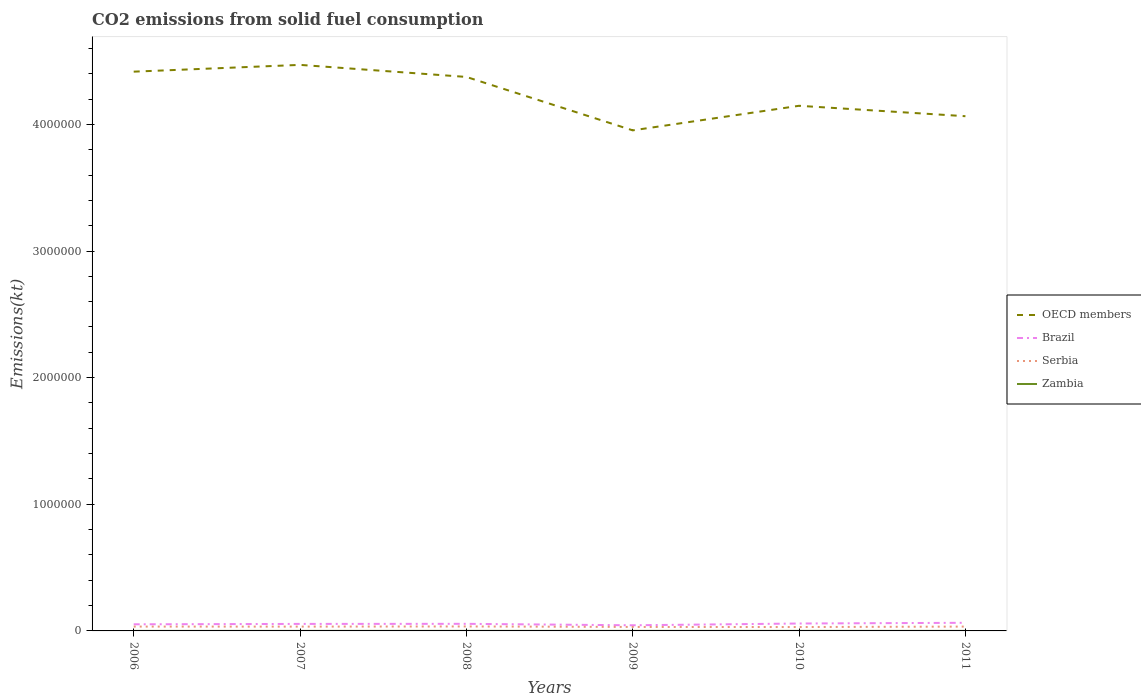Does the line corresponding to Zambia intersect with the line corresponding to OECD members?
Provide a short and direct response. No. Is the number of lines equal to the number of legend labels?
Offer a very short reply. Yes. Across all years, what is the maximum amount of CO2 emitted in Zambia?
Offer a very short reply. 132.01. In which year was the amount of CO2 emitted in Brazil maximum?
Give a very brief answer. 2009. What is the total amount of CO2 emitted in Serbia in the graph?
Keep it short and to the point. 238.36. What is the difference between the highest and the second highest amount of CO2 emitted in OECD members?
Keep it short and to the point. 5.17e+05. Is the amount of CO2 emitted in OECD members strictly greater than the amount of CO2 emitted in Serbia over the years?
Provide a short and direct response. No. How many years are there in the graph?
Your answer should be compact. 6. Does the graph contain any zero values?
Your response must be concise. No. Does the graph contain grids?
Keep it short and to the point. No. How many legend labels are there?
Ensure brevity in your answer.  4. What is the title of the graph?
Your answer should be compact. CO2 emissions from solid fuel consumption. Does "Bahrain" appear as one of the legend labels in the graph?
Your answer should be compact. No. What is the label or title of the Y-axis?
Your response must be concise. Emissions(kt). What is the Emissions(kt) of OECD members in 2006?
Ensure brevity in your answer.  4.42e+06. What is the Emissions(kt) of Brazil in 2006?
Make the answer very short. 5.23e+04. What is the Emissions(kt) of Serbia in 2006?
Your response must be concise. 3.42e+04. What is the Emissions(kt) of Zambia in 2006?
Make the answer very short. 132.01. What is the Emissions(kt) in OECD members in 2007?
Provide a short and direct response. 4.47e+06. What is the Emissions(kt) in Brazil in 2007?
Provide a succinct answer. 5.53e+04. What is the Emissions(kt) of Serbia in 2007?
Provide a short and direct response. 3.40e+04. What is the Emissions(kt) in Zambia in 2007?
Ensure brevity in your answer.  293.36. What is the Emissions(kt) in OECD members in 2008?
Your answer should be compact. 4.37e+06. What is the Emissions(kt) of Brazil in 2008?
Make the answer very short. 5.60e+04. What is the Emissions(kt) of Serbia in 2008?
Keep it short and to the point. 3.53e+04. What is the Emissions(kt) in Zambia in 2008?
Ensure brevity in your answer.  315.36. What is the Emissions(kt) of OECD members in 2009?
Your answer should be very brief. 3.95e+06. What is the Emissions(kt) of Brazil in 2009?
Provide a succinct answer. 4.45e+04. What is the Emissions(kt) in Serbia in 2009?
Your response must be concise. 3.14e+04. What is the Emissions(kt) in Zambia in 2009?
Offer a very short reply. 407.04. What is the Emissions(kt) in OECD members in 2010?
Your answer should be compact. 4.15e+06. What is the Emissions(kt) in Brazil in 2010?
Keep it short and to the point. 5.85e+04. What is the Emissions(kt) in Serbia in 2010?
Your answer should be compact. 3.07e+04. What is the Emissions(kt) in Zambia in 2010?
Make the answer very short. 381.37. What is the Emissions(kt) of OECD members in 2011?
Give a very brief answer. 4.06e+06. What is the Emissions(kt) of Brazil in 2011?
Make the answer very short. 6.42e+04. What is the Emissions(kt) in Serbia in 2011?
Make the answer very short. 3.42e+04. What is the Emissions(kt) in Zambia in 2011?
Provide a short and direct response. 267.69. Across all years, what is the maximum Emissions(kt) in OECD members?
Your answer should be very brief. 4.47e+06. Across all years, what is the maximum Emissions(kt) in Brazil?
Your answer should be very brief. 6.42e+04. Across all years, what is the maximum Emissions(kt) in Serbia?
Your answer should be compact. 3.53e+04. Across all years, what is the maximum Emissions(kt) in Zambia?
Your answer should be compact. 407.04. Across all years, what is the minimum Emissions(kt) in OECD members?
Your response must be concise. 3.95e+06. Across all years, what is the minimum Emissions(kt) in Brazil?
Your answer should be very brief. 4.45e+04. Across all years, what is the minimum Emissions(kt) in Serbia?
Provide a succinct answer. 3.07e+04. Across all years, what is the minimum Emissions(kt) in Zambia?
Offer a very short reply. 132.01. What is the total Emissions(kt) of OECD members in the graph?
Provide a succinct answer. 2.54e+07. What is the total Emissions(kt) in Brazil in the graph?
Offer a terse response. 3.31e+05. What is the total Emissions(kt) in Serbia in the graph?
Offer a terse response. 2.00e+05. What is the total Emissions(kt) of Zambia in the graph?
Provide a succinct answer. 1796.83. What is the difference between the Emissions(kt) in OECD members in 2006 and that in 2007?
Provide a short and direct response. -5.35e+04. What is the difference between the Emissions(kt) of Brazil in 2006 and that in 2007?
Keep it short and to the point. -3076.61. What is the difference between the Emissions(kt) in Serbia in 2006 and that in 2007?
Your response must be concise. 238.35. What is the difference between the Emissions(kt) of Zambia in 2006 and that in 2007?
Give a very brief answer. -161.35. What is the difference between the Emissions(kt) in OECD members in 2006 and that in 2008?
Provide a succinct answer. 4.17e+04. What is the difference between the Emissions(kt) of Brazil in 2006 and that in 2008?
Your answer should be compact. -3736.67. What is the difference between the Emissions(kt) of Serbia in 2006 and that in 2008?
Provide a succinct answer. -1056.1. What is the difference between the Emissions(kt) of Zambia in 2006 and that in 2008?
Provide a succinct answer. -183.35. What is the difference between the Emissions(kt) of OECD members in 2006 and that in 2009?
Keep it short and to the point. 4.64e+05. What is the difference between the Emissions(kt) of Brazil in 2006 and that in 2009?
Offer a very short reply. 7774.04. What is the difference between the Emissions(kt) of Serbia in 2006 and that in 2009?
Your answer should be very brief. 2882.26. What is the difference between the Emissions(kt) of Zambia in 2006 and that in 2009?
Ensure brevity in your answer.  -275.02. What is the difference between the Emissions(kt) in OECD members in 2006 and that in 2010?
Make the answer very short. 2.70e+05. What is the difference between the Emissions(kt) in Brazil in 2006 and that in 2010?
Your answer should be compact. -6274.24. What is the difference between the Emissions(kt) of Serbia in 2006 and that in 2010?
Make the answer very short. 3564.32. What is the difference between the Emissions(kt) of Zambia in 2006 and that in 2010?
Provide a short and direct response. -249.36. What is the difference between the Emissions(kt) of OECD members in 2006 and that in 2011?
Give a very brief answer. 3.52e+05. What is the difference between the Emissions(kt) of Brazil in 2006 and that in 2011?
Offer a terse response. -1.19e+04. What is the difference between the Emissions(kt) of Serbia in 2006 and that in 2011?
Keep it short and to the point. 62.34. What is the difference between the Emissions(kt) of Zambia in 2006 and that in 2011?
Your answer should be compact. -135.68. What is the difference between the Emissions(kt) in OECD members in 2007 and that in 2008?
Your answer should be very brief. 9.52e+04. What is the difference between the Emissions(kt) of Brazil in 2007 and that in 2008?
Your answer should be very brief. -660.06. What is the difference between the Emissions(kt) in Serbia in 2007 and that in 2008?
Provide a short and direct response. -1294.45. What is the difference between the Emissions(kt) of Zambia in 2007 and that in 2008?
Your response must be concise. -22. What is the difference between the Emissions(kt) of OECD members in 2007 and that in 2009?
Your response must be concise. 5.17e+05. What is the difference between the Emissions(kt) in Brazil in 2007 and that in 2009?
Provide a succinct answer. 1.09e+04. What is the difference between the Emissions(kt) in Serbia in 2007 and that in 2009?
Keep it short and to the point. 2643.91. What is the difference between the Emissions(kt) in Zambia in 2007 and that in 2009?
Your answer should be very brief. -113.68. What is the difference between the Emissions(kt) of OECD members in 2007 and that in 2010?
Offer a terse response. 3.23e+05. What is the difference between the Emissions(kt) of Brazil in 2007 and that in 2010?
Your answer should be very brief. -3197.62. What is the difference between the Emissions(kt) in Serbia in 2007 and that in 2010?
Offer a very short reply. 3325.97. What is the difference between the Emissions(kt) of Zambia in 2007 and that in 2010?
Ensure brevity in your answer.  -88.01. What is the difference between the Emissions(kt) in OECD members in 2007 and that in 2011?
Provide a short and direct response. 4.05e+05. What is the difference between the Emissions(kt) of Brazil in 2007 and that in 2011?
Keep it short and to the point. -8819.14. What is the difference between the Emissions(kt) in Serbia in 2007 and that in 2011?
Your answer should be very brief. -176.02. What is the difference between the Emissions(kt) in Zambia in 2007 and that in 2011?
Offer a very short reply. 25.67. What is the difference between the Emissions(kt) in OECD members in 2008 and that in 2009?
Give a very brief answer. 4.22e+05. What is the difference between the Emissions(kt) in Brazil in 2008 and that in 2009?
Your answer should be very brief. 1.15e+04. What is the difference between the Emissions(kt) in Serbia in 2008 and that in 2009?
Provide a succinct answer. 3938.36. What is the difference between the Emissions(kt) of Zambia in 2008 and that in 2009?
Make the answer very short. -91.67. What is the difference between the Emissions(kt) of OECD members in 2008 and that in 2010?
Ensure brevity in your answer.  2.28e+05. What is the difference between the Emissions(kt) in Brazil in 2008 and that in 2010?
Keep it short and to the point. -2537.56. What is the difference between the Emissions(kt) in Serbia in 2008 and that in 2010?
Make the answer very short. 4620.42. What is the difference between the Emissions(kt) of Zambia in 2008 and that in 2010?
Provide a succinct answer. -66.01. What is the difference between the Emissions(kt) of OECD members in 2008 and that in 2011?
Provide a succinct answer. 3.10e+05. What is the difference between the Emissions(kt) in Brazil in 2008 and that in 2011?
Keep it short and to the point. -8159.07. What is the difference between the Emissions(kt) of Serbia in 2008 and that in 2011?
Offer a terse response. 1118.43. What is the difference between the Emissions(kt) of Zambia in 2008 and that in 2011?
Your answer should be very brief. 47.67. What is the difference between the Emissions(kt) of OECD members in 2009 and that in 2010?
Give a very brief answer. -1.94e+05. What is the difference between the Emissions(kt) of Brazil in 2009 and that in 2010?
Your answer should be very brief. -1.40e+04. What is the difference between the Emissions(kt) in Serbia in 2009 and that in 2010?
Make the answer very short. 682.06. What is the difference between the Emissions(kt) in Zambia in 2009 and that in 2010?
Provide a short and direct response. 25.67. What is the difference between the Emissions(kt) of OECD members in 2009 and that in 2011?
Give a very brief answer. -1.12e+05. What is the difference between the Emissions(kt) in Brazil in 2009 and that in 2011?
Your answer should be very brief. -1.97e+04. What is the difference between the Emissions(kt) of Serbia in 2009 and that in 2011?
Make the answer very short. -2819.92. What is the difference between the Emissions(kt) in Zambia in 2009 and that in 2011?
Your response must be concise. 139.35. What is the difference between the Emissions(kt) in OECD members in 2010 and that in 2011?
Your answer should be compact. 8.23e+04. What is the difference between the Emissions(kt) of Brazil in 2010 and that in 2011?
Your response must be concise. -5621.51. What is the difference between the Emissions(kt) of Serbia in 2010 and that in 2011?
Ensure brevity in your answer.  -3501.99. What is the difference between the Emissions(kt) in Zambia in 2010 and that in 2011?
Make the answer very short. 113.68. What is the difference between the Emissions(kt) in OECD members in 2006 and the Emissions(kt) in Brazil in 2007?
Provide a succinct answer. 4.36e+06. What is the difference between the Emissions(kt) of OECD members in 2006 and the Emissions(kt) of Serbia in 2007?
Give a very brief answer. 4.38e+06. What is the difference between the Emissions(kt) of OECD members in 2006 and the Emissions(kt) of Zambia in 2007?
Your response must be concise. 4.42e+06. What is the difference between the Emissions(kt) of Brazil in 2006 and the Emissions(kt) of Serbia in 2007?
Your answer should be very brief. 1.83e+04. What is the difference between the Emissions(kt) in Brazil in 2006 and the Emissions(kt) in Zambia in 2007?
Offer a very short reply. 5.20e+04. What is the difference between the Emissions(kt) in Serbia in 2006 and the Emissions(kt) in Zambia in 2007?
Offer a terse response. 3.39e+04. What is the difference between the Emissions(kt) of OECD members in 2006 and the Emissions(kt) of Brazil in 2008?
Offer a terse response. 4.36e+06. What is the difference between the Emissions(kt) in OECD members in 2006 and the Emissions(kt) in Serbia in 2008?
Provide a succinct answer. 4.38e+06. What is the difference between the Emissions(kt) of OECD members in 2006 and the Emissions(kt) of Zambia in 2008?
Provide a short and direct response. 4.42e+06. What is the difference between the Emissions(kt) in Brazil in 2006 and the Emissions(kt) in Serbia in 2008?
Keep it short and to the point. 1.70e+04. What is the difference between the Emissions(kt) of Brazil in 2006 and the Emissions(kt) of Zambia in 2008?
Keep it short and to the point. 5.20e+04. What is the difference between the Emissions(kt) of Serbia in 2006 and the Emissions(kt) of Zambia in 2008?
Provide a short and direct response. 3.39e+04. What is the difference between the Emissions(kt) of OECD members in 2006 and the Emissions(kt) of Brazil in 2009?
Keep it short and to the point. 4.37e+06. What is the difference between the Emissions(kt) of OECD members in 2006 and the Emissions(kt) of Serbia in 2009?
Offer a very short reply. 4.38e+06. What is the difference between the Emissions(kt) in OECD members in 2006 and the Emissions(kt) in Zambia in 2009?
Your response must be concise. 4.42e+06. What is the difference between the Emissions(kt) in Brazil in 2006 and the Emissions(kt) in Serbia in 2009?
Provide a short and direct response. 2.09e+04. What is the difference between the Emissions(kt) in Brazil in 2006 and the Emissions(kt) in Zambia in 2009?
Keep it short and to the point. 5.19e+04. What is the difference between the Emissions(kt) in Serbia in 2006 and the Emissions(kt) in Zambia in 2009?
Provide a short and direct response. 3.38e+04. What is the difference between the Emissions(kt) in OECD members in 2006 and the Emissions(kt) in Brazil in 2010?
Your answer should be very brief. 4.36e+06. What is the difference between the Emissions(kt) of OECD members in 2006 and the Emissions(kt) of Serbia in 2010?
Provide a succinct answer. 4.39e+06. What is the difference between the Emissions(kt) of OECD members in 2006 and the Emissions(kt) of Zambia in 2010?
Ensure brevity in your answer.  4.42e+06. What is the difference between the Emissions(kt) in Brazil in 2006 and the Emissions(kt) in Serbia in 2010?
Ensure brevity in your answer.  2.16e+04. What is the difference between the Emissions(kt) in Brazil in 2006 and the Emissions(kt) in Zambia in 2010?
Keep it short and to the point. 5.19e+04. What is the difference between the Emissions(kt) of Serbia in 2006 and the Emissions(kt) of Zambia in 2010?
Offer a terse response. 3.39e+04. What is the difference between the Emissions(kt) in OECD members in 2006 and the Emissions(kt) in Brazil in 2011?
Keep it short and to the point. 4.35e+06. What is the difference between the Emissions(kt) in OECD members in 2006 and the Emissions(kt) in Serbia in 2011?
Provide a succinct answer. 4.38e+06. What is the difference between the Emissions(kt) of OECD members in 2006 and the Emissions(kt) of Zambia in 2011?
Your answer should be compact. 4.42e+06. What is the difference between the Emissions(kt) in Brazil in 2006 and the Emissions(kt) in Serbia in 2011?
Give a very brief answer. 1.81e+04. What is the difference between the Emissions(kt) in Brazil in 2006 and the Emissions(kt) in Zambia in 2011?
Offer a terse response. 5.20e+04. What is the difference between the Emissions(kt) in Serbia in 2006 and the Emissions(kt) in Zambia in 2011?
Your response must be concise. 3.40e+04. What is the difference between the Emissions(kt) of OECD members in 2007 and the Emissions(kt) of Brazil in 2008?
Make the answer very short. 4.41e+06. What is the difference between the Emissions(kt) of OECD members in 2007 and the Emissions(kt) of Serbia in 2008?
Ensure brevity in your answer.  4.43e+06. What is the difference between the Emissions(kt) of OECD members in 2007 and the Emissions(kt) of Zambia in 2008?
Provide a short and direct response. 4.47e+06. What is the difference between the Emissions(kt) of Brazil in 2007 and the Emissions(kt) of Serbia in 2008?
Provide a short and direct response. 2.00e+04. What is the difference between the Emissions(kt) in Brazil in 2007 and the Emissions(kt) in Zambia in 2008?
Keep it short and to the point. 5.50e+04. What is the difference between the Emissions(kt) in Serbia in 2007 and the Emissions(kt) in Zambia in 2008?
Offer a terse response. 3.37e+04. What is the difference between the Emissions(kt) in OECD members in 2007 and the Emissions(kt) in Brazil in 2009?
Provide a short and direct response. 4.43e+06. What is the difference between the Emissions(kt) of OECD members in 2007 and the Emissions(kt) of Serbia in 2009?
Provide a succinct answer. 4.44e+06. What is the difference between the Emissions(kt) in OECD members in 2007 and the Emissions(kt) in Zambia in 2009?
Keep it short and to the point. 4.47e+06. What is the difference between the Emissions(kt) in Brazil in 2007 and the Emissions(kt) in Serbia in 2009?
Your answer should be compact. 2.40e+04. What is the difference between the Emissions(kt) in Brazil in 2007 and the Emissions(kt) in Zambia in 2009?
Keep it short and to the point. 5.49e+04. What is the difference between the Emissions(kt) in Serbia in 2007 and the Emissions(kt) in Zambia in 2009?
Provide a succinct answer. 3.36e+04. What is the difference between the Emissions(kt) of OECD members in 2007 and the Emissions(kt) of Brazil in 2010?
Give a very brief answer. 4.41e+06. What is the difference between the Emissions(kt) in OECD members in 2007 and the Emissions(kt) in Serbia in 2010?
Keep it short and to the point. 4.44e+06. What is the difference between the Emissions(kt) of OECD members in 2007 and the Emissions(kt) of Zambia in 2010?
Provide a succinct answer. 4.47e+06. What is the difference between the Emissions(kt) of Brazil in 2007 and the Emissions(kt) of Serbia in 2010?
Make the answer very short. 2.47e+04. What is the difference between the Emissions(kt) in Brazil in 2007 and the Emissions(kt) in Zambia in 2010?
Your answer should be compact. 5.50e+04. What is the difference between the Emissions(kt) in Serbia in 2007 and the Emissions(kt) in Zambia in 2010?
Offer a very short reply. 3.36e+04. What is the difference between the Emissions(kt) in OECD members in 2007 and the Emissions(kt) in Brazil in 2011?
Offer a terse response. 4.41e+06. What is the difference between the Emissions(kt) of OECD members in 2007 and the Emissions(kt) of Serbia in 2011?
Provide a succinct answer. 4.44e+06. What is the difference between the Emissions(kt) of OECD members in 2007 and the Emissions(kt) of Zambia in 2011?
Your answer should be very brief. 4.47e+06. What is the difference between the Emissions(kt) in Brazil in 2007 and the Emissions(kt) in Serbia in 2011?
Give a very brief answer. 2.12e+04. What is the difference between the Emissions(kt) in Brazil in 2007 and the Emissions(kt) in Zambia in 2011?
Make the answer very short. 5.51e+04. What is the difference between the Emissions(kt) in Serbia in 2007 and the Emissions(kt) in Zambia in 2011?
Your answer should be compact. 3.37e+04. What is the difference between the Emissions(kt) in OECD members in 2008 and the Emissions(kt) in Brazil in 2009?
Offer a terse response. 4.33e+06. What is the difference between the Emissions(kt) of OECD members in 2008 and the Emissions(kt) of Serbia in 2009?
Provide a succinct answer. 4.34e+06. What is the difference between the Emissions(kt) of OECD members in 2008 and the Emissions(kt) of Zambia in 2009?
Provide a succinct answer. 4.37e+06. What is the difference between the Emissions(kt) of Brazil in 2008 and the Emissions(kt) of Serbia in 2009?
Your answer should be very brief. 2.46e+04. What is the difference between the Emissions(kt) of Brazil in 2008 and the Emissions(kt) of Zambia in 2009?
Your response must be concise. 5.56e+04. What is the difference between the Emissions(kt) of Serbia in 2008 and the Emissions(kt) of Zambia in 2009?
Make the answer very short. 3.49e+04. What is the difference between the Emissions(kt) in OECD members in 2008 and the Emissions(kt) in Brazil in 2010?
Your answer should be compact. 4.32e+06. What is the difference between the Emissions(kt) of OECD members in 2008 and the Emissions(kt) of Serbia in 2010?
Provide a succinct answer. 4.34e+06. What is the difference between the Emissions(kt) of OECD members in 2008 and the Emissions(kt) of Zambia in 2010?
Your response must be concise. 4.37e+06. What is the difference between the Emissions(kt) in Brazil in 2008 and the Emissions(kt) in Serbia in 2010?
Offer a very short reply. 2.53e+04. What is the difference between the Emissions(kt) of Brazil in 2008 and the Emissions(kt) of Zambia in 2010?
Provide a short and direct response. 5.56e+04. What is the difference between the Emissions(kt) of Serbia in 2008 and the Emissions(kt) of Zambia in 2010?
Your answer should be compact. 3.49e+04. What is the difference between the Emissions(kt) in OECD members in 2008 and the Emissions(kt) in Brazil in 2011?
Offer a very short reply. 4.31e+06. What is the difference between the Emissions(kt) in OECD members in 2008 and the Emissions(kt) in Serbia in 2011?
Give a very brief answer. 4.34e+06. What is the difference between the Emissions(kt) of OECD members in 2008 and the Emissions(kt) of Zambia in 2011?
Keep it short and to the point. 4.37e+06. What is the difference between the Emissions(kt) in Brazil in 2008 and the Emissions(kt) in Serbia in 2011?
Provide a short and direct response. 2.18e+04. What is the difference between the Emissions(kt) of Brazil in 2008 and the Emissions(kt) of Zambia in 2011?
Offer a very short reply. 5.57e+04. What is the difference between the Emissions(kt) in Serbia in 2008 and the Emissions(kt) in Zambia in 2011?
Your answer should be compact. 3.50e+04. What is the difference between the Emissions(kt) in OECD members in 2009 and the Emissions(kt) in Brazil in 2010?
Ensure brevity in your answer.  3.89e+06. What is the difference between the Emissions(kt) in OECD members in 2009 and the Emissions(kt) in Serbia in 2010?
Your answer should be very brief. 3.92e+06. What is the difference between the Emissions(kt) in OECD members in 2009 and the Emissions(kt) in Zambia in 2010?
Offer a very short reply. 3.95e+06. What is the difference between the Emissions(kt) of Brazil in 2009 and the Emissions(kt) of Serbia in 2010?
Your answer should be very brief. 1.38e+04. What is the difference between the Emissions(kt) of Brazil in 2009 and the Emissions(kt) of Zambia in 2010?
Your response must be concise. 4.41e+04. What is the difference between the Emissions(kt) of Serbia in 2009 and the Emissions(kt) of Zambia in 2010?
Provide a succinct answer. 3.10e+04. What is the difference between the Emissions(kt) of OECD members in 2009 and the Emissions(kt) of Brazil in 2011?
Provide a succinct answer. 3.89e+06. What is the difference between the Emissions(kt) in OECD members in 2009 and the Emissions(kt) in Serbia in 2011?
Give a very brief answer. 3.92e+06. What is the difference between the Emissions(kt) of OECD members in 2009 and the Emissions(kt) of Zambia in 2011?
Ensure brevity in your answer.  3.95e+06. What is the difference between the Emissions(kt) of Brazil in 2009 and the Emissions(kt) of Serbia in 2011?
Provide a short and direct response. 1.03e+04. What is the difference between the Emissions(kt) in Brazil in 2009 and the Emissions(kt) in Zambia in 2011?
Provide a succinct answer. 4.42e+04. What is the difference between the Emissions(kt) of Serbia in 2009 and the Emissions(kt) of Zambia in 2011?
Provide a short and direct response. 3.11e+04. What is the difference between the Emissions(kt) in OECD members in 2010 and the Emissions(kt) in Brazil in 2011?
Give a very brief answer. 4.08e+06. What is the difference between the Emissions(kt) of OECD members in 2010 and the Emissions(kt) of Serbia in 2011?
Make the answer very short. 4.11e+06. What is the difference between the Emissions(kt) in OECD members in 2010 and the Emissions(kt) in Zambia in 2011?
Provide a succinct answer. 4.15e+06. What is the difference between the Emissions(kt) of Brazil in 2010 and the Emissions(kt) of Serbia in 2011?
Offer a very short reply. 2.44e+04. What is the difference between the Emissions(kt) in Brazil in 2010 and the Emissions(kt) in Zambia in 2011?
Offer a very short reply. 5.83e+04. What is the difference between the Emissions(kt) in Serbia in 2010 and the Emissions(kt) in Zambia in 2011?
Offer a terse response. 3.04e+04. What is the average Emissions(kt) of OECD members per year?
Your response must be concise. 4.24e+06. What is the average Emissions(kt) in Brazil per year?
Your answer should be very brief. 5.51e+04. What is the average Emissions(kt) of Serbia per year?
Give a very brief answer. 3.33e+04. What is the average Emissions(kt) in Zambia per year?
Your answer should be very brief. 299.47. In the year 2006, what is the difference between the Emissions(kt) of OECD members and Emissions(kt) of Brazil?
Provide a short and direct response. 4.36e+06. In the year 2006, what is the difference between the Emissions(kt) in OECD members and Emissions(kt) in Serbia?
Your response must be concise. 4.38e+06. In the year 2006, what is the difference between the Emissions(kt) in OECD members and Emissions(kt) in Zambia?
Keep it short and to the point. 4.42e+06. In the year 2006, what is the difference between the Emissions(kt) in Brazil and Emissions(kt) in Serbia?
Offer a terse response. 1.80e+04. In the year 2006, what is the difference between the Emissions(kt) of Brazil and Emissions(kt) of Zambia?
Your answer should be very brief. 5.21e+04. In the year 2006, what is the difference between the Emissions(kt) of Serbia and Emissions(kt) of Zambia?
Your answer should be compact. 3.41e+04. In the year 2007, what is the difference between the Emissions(kt) of OECD members and Emissions(kt) of Brazil?
Offer a terse response. 4.41e+06. In the year 2007, what is the difference between the Emissions(kt) in OECD members and Emissions(kt) in Serbia?
Your response must be concise. 4.44e+06. In the year 2007, what is the difference between the Emissions(kt) of OECD members and Emissions(kt) of Zambia?
Your answer should be compact. 4.47e+06. In the year 2007, what is the difference between the Emissions(kt) of Brazil and Emissions(kt) of Serbia?
Your answer should be very brief. 2.13e+04. In the year 2007, what is the difference between the Emissions(kt) in Brazil and Emissions(kt) in Zambia?
Your answer should be very brief. 5.51e+04. In the year 2007, what is the difference between the Emissions(kt) in Serbia and Emissions(kt) in Zambia?
Provide a succinct answer. 3.37e+04. In the year 2008, what is the difference between the Emissions(kt) in OECD members and Emissions(kt) in Brazil?
Offer a very short reply. 4.32e+06. In the year 2008, what is the difference between the Emissions(kt) in OECD members and Emissions(kt) in Serbia?
Offer a terse response. 4.34e+06. In the year 2008, what is the difference between the Emissions(kt) in OECD members and Emissions(kt) in Zambia?
Offer a terse response. 4.37e+06. In the year 2008, what is the difference between the Emissions(kt) of Brazil and Emissions(kt) of Serbia?
Give a very brief answer. 2.07e+04. In the year 2008, what is the difference between the Emissions(kt) in Brazil and Emissions(kt) in Zambia?
Ensure brevity in your answer.  5.57e+04. In the year 2008, what is the difference between the Emissions(kt) in Serbia and Emissions(kt) in Zambia?
Keep it short and to the point. 3.50e+04. In the year 2009, what is the difference between the Emissions(kt) of OECD members and Emissions(kt) of Brazil?
Ensure brevity in your answer.  3.91e+06. In the year 2009, what is the difference between the Emissions(kt) of OECD members and Emissions(kt) of Serbia?
Keep it short and to the point. 3.92e+06. In the year 2009, what is the difference between the Emissions(kt) of OECD members and Emissions(kt) of Zambia?
Offer a terse response. 3.95e+06. In the year 2009, what is the difference between the Emissions(kt) of Brazil and Emissions(kt) of Serbia?
Offer a terse response. 1.31e+04. In the year 2009, what is the difference between the Emissions(kt) of Brazil and Emissions(kt) of Zambia?
Offer a very short reply. 4.41e+04. In the year 2009, what is the difference between the Emissions(kt) in Serbia and Emissions(kt) in Zambia?
Keep it short and to the point. 3.10e+04. In the year 2010, what is the difference between the Emissions(kt) of OECD members and Emissions(kt) of Brazil?
Provide a succinct answer. 4.09e+06. In the year 2010, what is the difference between the Emissions(kt) of OECD members and Emissions(kt) of Serbia?
Ensure brevity in your answer.  4.12e+06. In the year 2010, what is the difference between the Emissions(kt) in OECD members and Emissions(kt) in Zambia?
Your answer should be very brief. 4.15e+06. In the year 2010, what is the difference between the Emissions(kt) in Brazil and Emissions(kt) in Serbia?
Provide a succinct answer. 2.79e+04. In the year 2010, what is the difference between the Emissions(kt) in Brazil and Emissions(kt) in Zambia?
Ensure brevity in your answer.  5.82e+04. In the year 2010, what is the difference between the Emissions(kt) in Serbia and Emissions(kt) in Zambia?
Give a very brief answer. 3.03e+04. In the year 2011, what is the difference between the Emissions(kt) of OECD members and Emissions(kt) of Brazil?
Keep it short and to the point. 4.00e+06. In the year 2011, what is the difference between the Emissions(kt) of OECD members and Emissions(kt) of Serbia?
Your answer should be very brief. 4.03e+06. In the year 2011, what is the difference between the Emissions(kt) in OECD members and Emissions(kt) in Zambia?
Make the answer very short. 4.06e+06. In the year 2011, what is the difference between the Emissions(kt) in Brazil and Emissions(kt) in Serbia?
Your answer should be very brief. 3.00e+04. In the year 2011, what is the difference between the Emissions(kt) in Brazil and Emissions(kt) in Zambia?
Give a very brief answer. 6.39e+04. In the year 2011, what is the difference between the Emissions(kt) of Serbia and Emissions(kt) of Zambia?
Offer a very short reply. 3.39e+04. What is the ratio of the Emissions(kt) in Brazil in 2006 to that in 2007?
Give a very brief answer. 0.94. What is the ratio of the Emissions(kt) in Zambia in 2006 to that in 2007?
Ensure brevity in your answer.  0.45. What is the ratio of the Emissions(kt) of OECD members in 2006 to that in 2008?
Your answer should be compact. 1.01. What is the ratio of the Emissions(kt) of Serbia in 2006 to that in 2008?
Provide a succinct answer. 0.97. What is the ratio of the Emissions(kt) in Zambia in 2006 to that in 2008?
Offer a terse response. 0.42. What is the ratio of the Emissions(kt) in OECD members in 2006 to that in 2009?
Offer a very short reply. 1.12. What is the ratio of the Emissions(kt) of Brazil in 2006 to that in 2009?
Keep it short and to the point. 1.17. What is the ratio of the Emissions(kt) of Serbia in 2006 to that in 2009?
Provide a succinct answer. 1.09. What is the ratio of the Emissions(kt) in Zambia in 2006 to that in 2009?
Ensure brevity in your answer.  0.32. What is the ratio of the Emissions(kt) in OECD members in 2006 to that in 2010?
Make the answer very short. 1.06. What is the ratio of the Emissions(kt) of Brazil in 2006 to that in 2010?
Your answer should be compact. 0.89. What is the ratio of the Emissions(kt) of Serbia in 2006 to that in 2010?
Your response must be concise. 1.12. What is the ratio of the Emissions(kt) in Zambia in 2006 to that in 2010?
Your response must be concise. 0.35. What is the ratio of the Emissions(kt) in OECD members in 2006 to that in 2011?
Your answer should be very brief. 1.09. What is the ratio of the Emissions(kt) in Brazil in 2006 to that in 2011?
Your answer should be very brief. 0.81. What is the ratio of the Emissions(kt) of Zambia in 2006 to that in 2011?
Offer a terse response. 0.49. What is the ratio of the Emissions(kt) in OECD members in 2007 to that in 2008?
Ensure brevity in your answer.  1.02. What is the ratio of the Emissions(kt) in Brazil in 2007 to that in 2008?
Your answer should be compact. 0.99. What is the ratio of the Emissions(kt) of Serbia in 2007 to that in 2008?
Keep it short and to the point. 0.96. What is the ratio of the Emissions(kt) of Zambia in 2007 to that in 2008?
Your response must be concise. 0.93. What is the ratio of the Emissions(kt) of OECD members in 2007 to that in 2009?
Your answer should be compact. 1.13. What is the ratio of the Emissions(kt) in Brazil in 2007 to that in 2009?
Your response must be concise. 1.24. What is the ratio of the Emissions(kt) in Serbia in 2007 to that in 2009?
Keep it short and to the point. 1.08. What is the ratio of the Emissions(kt) of Zambia in 2007 to that in 2009?
Offer a very short reply. 0.72. What is the ratio of the Emissions(kt) in OECD members in 2007 to that in 2010?
Provide a short and direct response. 1.08. What is the ratio of the Emissions(kt) in Brazil in 2007 to that in 2010?
Ensure brevity in your answer.  0.95. What is the ratio of the Emissions(kt) of Serbia in 2007 to that in 2010?
Provide a short and direct response. 1.11. What is the ratio of the Emissions(kt) in Zambia in 2007 to that in 2010?
Keep it short and to the point. 0.77. What is the ratio of the Emissions(kt) in OECD members in 2007 to that in 2011?
Give a very brief answer. 1.1. What is the ratio of the Emissions(kt) of Brazil in 2007 to that in 2011?
Give a very brief answer. 0.86. What is the ratio of the Emissions(kt) of Zambia in 2007 to that in 2011?
Offer a terse response. 1.1. What is the ratio of the Emissions(kt) of OECD members in 2008 to that in 2009?
Provide a short and direct response. 1.11. What is the ratio of the Emissions(kt) of Brazil in 2008 to that in 2009?
Keep it short and to the point. 1.26. What is the ratio of the Emissions(kt) in Serbia in 2008 to that in 2009?
Your answer should be compact. 1.13. What is the ratio of the Emissions(kt) of Zambia in 2008 to that in 2009?
Make the answer very short. 0.77. What is the ratio of the Emissions(kt) in OECD members in 2008 to that in 2010?
Ensure brevity in your answer.  1.05. What is the ratio of the Emissions(kt) in Brazil in 2008 to that in 2010?
Your answer should be very brief. 0.96. What is the ratio of the Emissions(kt) in Serbia in 2008 to that in 2010?
Ensure brevity in your answer.  1.15. What is the ratio of the Emissions(kt) of Zambia in 2008 to that in 2010?
Offer a terse response. 0.83. What is the ratio of the Emissions(kt) in OECD members in 2008 to that in 2011?
Your response must be concise. 1.08. What is the ratio of the Emissions(kt) in Brazil in 2008 to that in 2011?
Offer a terse response. 0.87. What is the ratio of the Emissions(kt) of Serbia in 2008 to that in 2011?
Give a very brief answer. 1.03. What is the ratio of the Emissions(kt) of Zambia in 2008 to that in 2011?
Offer a terse response. 1.18. What is the ratio of the Emissions(kt) in OECD members in 2009 to that in 2010?
Give a very brief answer. 0.95. What is the ratio of the Emissions(kt) of Brazil in 2009 to that in 2010?
Your response must be concise. 0.76. What is the ratio of the Emissions(kt) of Serbia in 2009 to that in 2010?
Your response must be concise. 1.02. What is the ratio of the Emissions(kt) of Zambia in 2009 to that in 2010?
Offer a very short reply. 1.07. What is the ratio of the Emissions(kt) of OECD members in 2009 to that in 2011?
Provide a short and direct response. 0.97. What is the ratio of the Emissions(kt) of Brazil in 2009 to that in 2011?
Your answer should be compact. 0.69. What is the ratio of the Emissions(kt) of Serbia in 2009 to that in 2011?
Ensure brevity in your answer.  0.92. What is the ratio of the Emissions(kt) in Zambia in 2009 to that in 2011?
Provide a succinct answer. 1.52. What is the ratio of the Emissions(kt) in OECD members in 2010 to that in 2011?
Keep it short and to the point. 1.02. What is the ratio of the Emissions(kt) in Brazil in 2010 to that in 2011?
Provide a succinct answer. 0.91. What is the ratio of the Emissions(kt) of Serbia in 2010 to that in 2011?
Offer a terse response. 0.9. What is the ratio of the Emissions(kt) in Zambia in 2010 to that in 2011?
Your answer should be compact. 1.42. What is the difference between the highest and the second highest Emissions(kt) in OECD members?
Your response must be concise. 5.35e+04. What is the difference between the highest and the second highest Emissions(kt) of Brazil?
Offer a very short reply. 5621.51. What is the difference between the highest and the second highest Emissions(kt) of Serbia?
Ensure brevity in your answer.  1056.1. What is the difference between the highest and the second highest Emissions(kt) of Zambia?
Make the answer very short. 25.67. What is the difference between the highest and the lowest Emissions(kt) in OECD members?
Make the answer very short. 5.17e+05. What is the difference between the highest and the lowest Emissions(kt) in Brazil?
Make the answer very short. 1.97e+04. What is the difference between the highest and the lowest Emissions(kt) in Serbia?
Provide a short and direct response. 4620.42. What is the difference between the highest and the lowest Emissions(kt) in Zambia?
Your response must be concise. 275.02. 